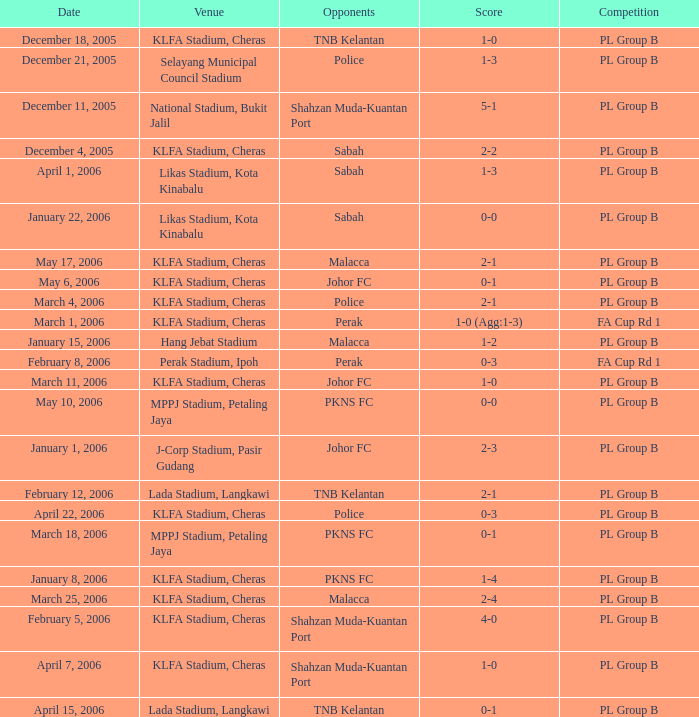Which site holds a battle in pl group b, and possesses a score of 2-2? KLFA Stadium, Cheras. 